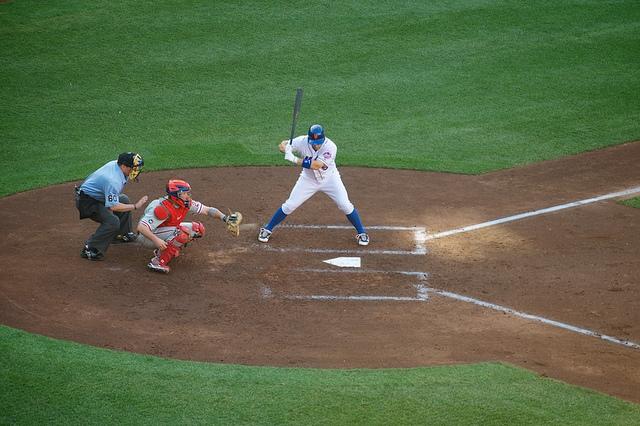What color is the batter's helmet?
Short answer required. Blue. What sport are they playing?
Be succinct. Baseball. Is the man swinging the bat?
Keep it brief. No. Does the batter have on gray socks?
Be succinct. No. What is the man in blue behind the catchers' position?
Quick response, please. Umpire. What is the batter doing?
Answer briefly. Batting. 